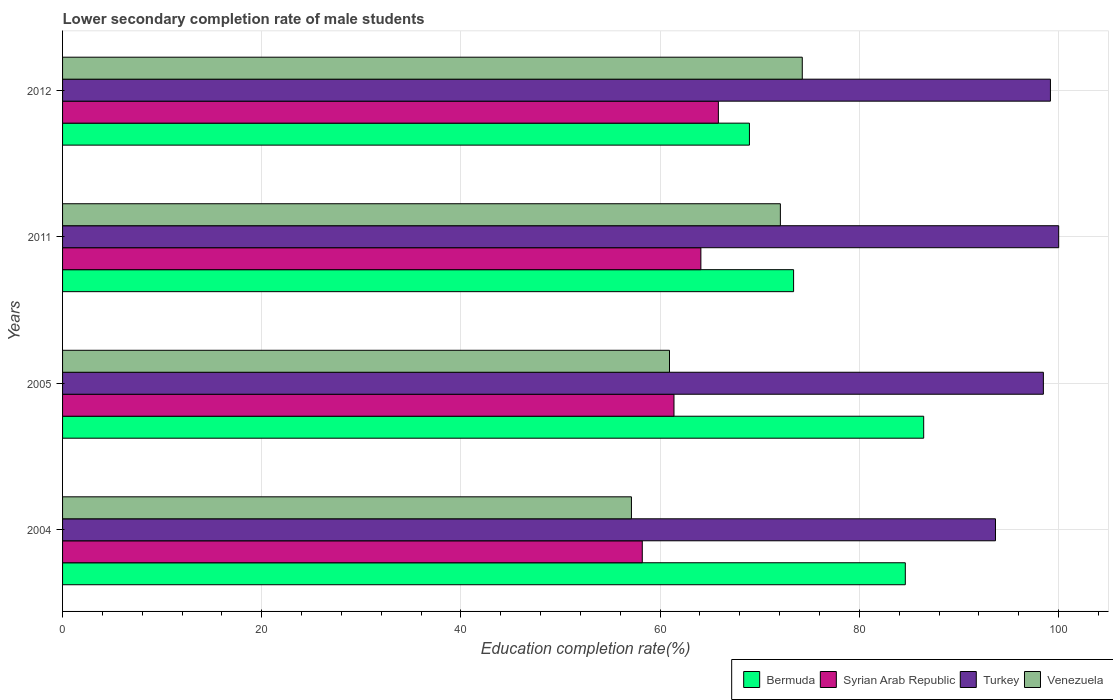How many different coloured bars are there?
Your response must be concise. 4. How many groups of bars are there?
Give a very brief answer. 4. Are the number of bars per tick equal to the number of legend labels?
Offer a very short reply. Yes. Are the number of bars on each tick of the Y-axis equal?
Make the answer very short. Yes. How many bars are there on the 2nd tick from the bottom?
Your response must be concise. 4. In how many cases, is the number of bars for a given year not equal to the number of legend labels?
Keep it short and to the point. 0. What is the lower secondary completion rate of male students in Syrian Arab Republic in 2005?
Provide a short and direct response. 61.39. Across all years, what is the maximum lower secondary completion rate of male students in Bermuda?
Make the answer very short. 86.46. Across all years, what is the minimum lower secondary completion rate of male students in Turkey?
Offer a very short reply. 93.67. In which year was the lower secondary completion rate of male students in Syrian Arab Republic maximum?
Ensure brevity in your answer.  2012. In which year was the lower secondary completion rate of male students in Syrian Arab Republic minimum?
Make the answer very short. 2004. What is the total lower secondary completion rate of male students in Bermuda in the graph?
Keep it short and to the point. 313.44. What is the difference between the lower secondary completion rate of male students in Venezuela in 2005 and that in 2012?
Your answer should be very brief. -13.33. What is the difference between the lower secondary completion rate of male students in Bermuda in 2004 and the lower secondary completion rate of male students in Venezuela in 2005?
Offer a terse response. 23.68. What is the average lower secondary completion rate of male students in Syrian Arab Republic per year?
Offer a very short reply. 62.38. In the year 2004, what is the difference between the lower secondary completion rate of male students in Bermuda and lower secondary completion rate of male students in Venezuela?
Your response must be concise. 27.5. What is the ratio of the lower secondary completion rate of male students in Syrian Arab Republic in 2004 to that in 2012?
Offer a very short reply. 0.88. What is the difference between the highest and the second highest lower secondary completion rate of male students in Turkey?
Your answer should be very brief. 0.83. What is the difference between the highest and the lowest lower secondary completion rate of male students in Turkey?
Offer a very short reply. 6.35. In how many years, is the lower secondary completion rate of male students in Turkey greater than the average lower secondary completion rate of male students in Turkey taken over all years?
Keep it short and to the point. 3. What does the 1st bar from the top in 2005 represents?
Offer a very short reply. Venezuela. What does the 4th bar from the bottom in 2011 represents?
Your answer should be compact. Venezuela. How many bars are there?
Offer a very short reply. 16. Are all the bars in the graph horizontal?
Ensure brevity in your answer.  Yes. Are the values on the major ticks of X-axis written in scientific E-notation?
Offer a very short reply. No. Does the graph contain any zero values?
Your answer should be very brief. No. Does the graph contain grids?
Offer a terse response. Yes. What is the title of the graph?
Offer a very short reply. Lower secondary completion rate of male students. Does "Middle East & North Africa (all income levels)" appear as one of the legend labels in the graph?
Your answer should be very brief. No. What is the label or title of the X-axis?
Your answer should be compact. Education completion rate(%). What is the Education completion rate(%) of Bermuda in 2004?
Your answer should be very brief. 84.62. What is the Education completion rate(%) of Syrian Arab Republic in 2004?
Ensure brevity in your answer.  58.21. What is the Education completion rate(%) of Turkey in 2004?
Keep it short and to the point. 93.67. What is the Education completion rate(%) in Venezuela in 2004?
Make the answer very short. 57.12. What is the Education completion rate(%) of Bermuda in 2005?
Offer a very short reply. 86.46. What is the Education completion rate(%) of Syrian Arab Republic in 2005?
Keep it short and to the point. 61.39. What is the Education completion rate(%) in Turkey in 2005?
Offer a very short reply. 98.48. What is the Education completion rate(%) in Venezuela in 2005?
Give a very brief answer. 60.94. What is the Education completion rate(%) in Bermuda in 2011?
Your answer should be compact. 73.4. What is the Education completion rate(%) of Syrian Arab Republic in 2011?
Your answer should be very brief. 64.09. What is the Education completion rate(%) of Turkey in 2011?
Offer a very short reply. 100.01. What is the Education completion rate(%) in Venezuela in 2011?
Keep it short and to the point. 72.07. What is the Education completion rate(%) of Bermuda in 2012?
Ensure brevity in your answer.  68.97. What is the Education completion rate(%) in Syrian Arab Republic in 2012?
Ensure brevity in your answer.  65.85. What is the Education completion rate(%) in Turkey in 2012?
Give a very brief answer. 99.19. What is the Education completion rate(%) in Venezuela in 2012?
Your response must be concise. 74.27. Across all years, what is the maximum Education completion rate(%) of Bermuda?
Make the answer very short. 86.46. Across all years, what is the maximum Education completion rate(%) in Syrian Arab Republic?
Your answer should be compact. 65.85. Across all years, what is the maximum Education completion rate(%) of Turkey?
Offer a terse response. 100.01. Across all years, what is the maximum Education completion rate(%) of Venezuela?
Offer a very short reply. 74.27. Across all years, what is the minimum Education completion rate(%) of Bermuda?
Your answer should be very brief. 68.97. Across all years, what is the minimum Education completion rate(%) of Syrian Arab Republic?
Provide a short and direct response. 58.21. Across all years, what is the minimum Education completion rate(%) of Turkey?
Keep it short and to the point. 93.67. Across all years, what is the minimum Education completion rate(%) of Venezuela?
Offer a terse response. 57.12. What is the total Education completion rate(%) in Bermuda in the graph?
Offer a very short reply. 313.44. What is the total Education completion rate(%) of Syrian Arab Republic in the graph?
Ensure brevity in your answer.  249.53. What is the total Education completion rate(%) in Turkey in the graph?
Your answer should be compact. 391.35. What is the total Education completion rate(%) of Venezuela in the graph?
Your answer should be very brief. 264.4. What is the difference between the Education completion rate(%) in Bermuda in 2004 and that in 2005?
Offer a very short reply. -1.85. What is the difference between the Education completion rate(%) of Syrian Arab Republic in 2004 and that in 2005?
Make the answer very short. -3.18. What is the difference between the Education completion rate(%) in Turkey in 2004 and that in 2005?
Your answer should be very brief. -4.81. What is the difference between the Education completion rate(%) of Venezuela in 2004 and that in 2005?
Provide a short and direct response. -3.82. What is the difference between the Education completion rate(%) of Bermuda in 2004 and that in 2011?
Offer a terse response. 11.22. What is the difference between the Education completion rate(%) of Syrian Arab Republic in 2004 and that in 2011?
Offer a very short reply. -5.88. What is the difference between the Education completion rate(%) of Turkey in 2004 and that in 2011?
Offer a terse response. -6.35. What is the difference between the Education completion rate(%) in Venezuela in 2004 and that in 2011?
Offer a very short reply. -14.95. What is the difference between the Education completion rate(%) of Bermuda in 2004 and that in 2012?
Keep it short and to the point. 15.65. What is the difference between the Education completion rate(%) of Syrian Arab Republic in 2004 and that in 2012?
Your answer should be very brief. -7.64. What is the difference between the Education completion rate(%) in Turkey in 2004 and that in 2012?
Your response must be concise. -5.52. What is the difference between the Education completion rate(%) in Venezuela in 2004 and that in 2012?
Your answer should be very brief. -17.15. What is the difference between the Education completion rate(%) in Bermuda in 2005 and that in 2011?
Provide a short and direct response. 13.06. What is the difference between the Education completion rate(%) in Syrian Arab Republic in 2005 and that in 2011?
Ensure brevity in your answer.  -2.7. What is the difference between the Education completion rate(%) in Turkey in 2005 and that in 2011?
Provide a short and direct response. -1.54. What is the difference between the Education completion rate(%) of Venezuela in 2005 and that in 2011?
Your answer should be very brief. -11.13. What is the difference between the Education completion rate(%) of Bermuda in 2005 and that in 2012?
Offer a terse response. 17.5. What is the difference between the Education completion rate(%) of Syrian Arab Republic in 2005 and that in 2012?
Your response must be concise. -4.46. What is the difference between the Education completion rate(%) in Turkey in 2005 and that in 2012?
Offer a terse response. -0.71. What is the difference between the Education completion rate(%) of Venezuela in 2005 and that in 2012?
Provide a succinct answer. -13.33. What is the difference between the Education completion rate(%) in Bermuda in 2011 and that in 2012?
Offer a terse response. 4.43. What is the difference between the Education completion rate(%) of Syrian Arab Republic in 2011 and that in 2012?
Your answer should be compact. -1.76. What is the difference between the Education completion rate(%) in Turkey in 2011 and that in 2012?
Your response must be concise. 0.83. What is the difference between the Education completion rate(%) of Venezuela in 2011 and that in 2012?
Ensure brevity in your answer.  -2.2. What is the difference between the Education completion rate(%) of Bermuda in 2004 and the Education completion rate(%) of Syrian Arab Republic in 2005?
Offer a very short reply. 23.23. What is the difference between the Education completion rate(%) of Bermuda in 2004 and the Education completion rate(%) of Turkey in 2005?
Provide a short and direct response. -13.86. What is the difference between the Education completion rate(%) in Bermuda in 2004 and the Education completion rate(%) in Venezuela in 2005?
Make the answer very short. 23.68. What is the difference between the Education completion rate(%) in Syrian Arab Republic in 2004 and the Education completion rate(%) in Turkey in 2005?
Give a very brief answer. -40.27. What is the difference between the Education completion rate(%) of Syrian Arab Republic in 2004 and the Education completion rate(%) of Venezuela in 2005?
Provide a short and direct response. -2.73. What is the difference between the Education completion rate(%) in Turkey in 2004 and the Education completion rate(%) in Venezuela in 2005?
Provide a short and direct response. 32.73. What is the difference between the Education completion rate(%) in Bermuda in 2004 and the Education completion rate(%) in Syrian Arab Republic in 2011?
Your response must be concise. 20.53. What is the difference between the Education completion rate(%) of Bermuda in 2004 and the Education completion rate(%) of Turkey in 2011?
Your response must be concise. -15.4. What is the difference between the Education completion rate(%) of Bermuda in 2004 and the Education completion rate(%) of Venezuela in 2011?
Keep it short and to the point. 12.54. What is the difference between the Education completion rate(%) of Syrian Arab Republic in 2004 and the Education completion rate(%) of Turkey in 2011?
Give a very brief answer. -41.81. What is the difference between the Education completion rate(%) in Syrian Arab Republic in 2004 and the Education completion rate(%) in Venezuela in 2011?
Your response must be concise. -13.87. What is the difference between the Education completion rate(%) of Turkey in 2004 and the Education completion rate(%) of Venezuela in 2011?
Ensure brevity in your answer.  21.6. What is the difference between the Education completion rate(%) of Bermuda in 2004 and the Education completion rate(%) of Syrian Arab Republic in 2012?
Provide a succinct answer. 18.77. What is the difference between the Education completion rate(%) in Bermuda in 2004 and the Education completion rate(%) in Turkey in 2012?
Provide a short and direct response. -14.57. What is the difference between the Education completion rate(%) in Bermuda in 2004 and the Education completion rate(%) in Venezuela in 2012?
Offer a very short reply. 10.35. What is the difference between the Education completion rate(%) in Syrian Arab Republic in 2004 and the Education completion rate(%) in Turkey in 2012?
Give a very brief answer. -40.98. What is the difference between the Education completion rate(%) of Syrian Arab Republic in 2004 and the Education completion rate(%) of Venezuela in 2012?
Make the answer very short. -16.06. What is the difference between the Education completion rate(%) in Turkey in 2004 and the Education completion rate(%) in Venezuela in 2012?
Ensure brevity in your answer.  19.4. What is the difference between the Education completion rate(%) in Bermuda in 2005 and the Education completion rate(%) in Syrian Arab Republic in 2011?
Offer a very short reply. 22.37. What is the difference between the Education completion rate(%) of Bermuda in 2005 and the Education completion rate(%) of Turkey in 2011?
Make the answer very short. -13.55. What is the difference between the Education completion rate(%) in Bermuda in 2005 and the Education completion rate(%) in Venezuela in 2011?
Make the answer very short. 14.39. What is the difference between the Education completion rate(%) of Syrian Arab Republic in 2005 and the Education completion rate(%) of Turkey in 2011?
Make the answer very short. -38.63. What is the difference between the Education completion rate(%) of Syrian Arab Republic in 2005 and the Education completion rate(%) of Venezuela in 2011?
Provide a short and direct response. -10.68. What is the difference between the Education completion rate(%) of Turkey in 2005 and the Education completion rate(%) of Venezuela in 2011?
Your response must be concise. 26.41. What is the difference between the Education completion rate(%) in Bermuda in 2005 and the Education completion rate(%) in Syrian Arab Republic in 2012?
Your response must be concise. 20.61. What is the difference between the Education completion rate(%) in Bermuda in 2005 and the Education completion rate(%) in Turkey in 2012?
Keep it short and to the point. -12.73. What is the difference between the Education completion rate(%) of Bermuda in 2005 and the Education completion rate(%) of Venezuela in 2012?
Make the answer very short. 12.19. What is the difference between the Education completion rate(%) of Syrian Arab Republic in 2005 and the Education completion rate(%) of Turkey in 2012?
Offer a terse response. -37.8. What is the difference between the Education completion rate(%) in Syrian Arab Republic in 2005 and the Education completion rate(%) in Venezuela in 2012?
Your answer should be very brief. -12.88. What is the difference between the Education completion rate(%) of Turkey in 2005 and the Education completion rate(%) of Venezuela in 2012?
Provide a short and direct response. 24.21. What is the difference between the Education completion rate(%) in Bermuda in 2011 and the Education completion rate(%) in Syrian Arab Republic in 2012?
Give a very brief answer. 7.55. What is the difference between the Education completion rate(%) of Bermuda in 2011 and the Education completion rate(%) of Turkey in 2012?
Offer a very short reply. -25.79. What is the difference between the Education completion rate(%) in Bermuda in 2011 and the Education completion rate(%) in Venezuela in 2012?
Give a very brief answer. -0.87. What is the difference between the Education completion rate(%) in Syrian Arab Republic in 2011 and the Education completion rate(%) in Turkey in 2012?
Offer a very short reply. -35.1. What is the difference between the Education completion rate(%) in Syrian Arab Republic in 2011 and the Education completion rate(%) in Venezuela in 2012?
Provide a short and direct response. -10.18. What is the difference between the Education completion rate(%) in Turkey in 2011 and the Education completion rate(%) in Venezuela in 2012?
Give a very brief answer. 25.74. What is the average Education completion rate(%) of Bermuda per year?
Your answer should be very brief. 78.36. What is the average Education completion rate(%) in Syrian Arab Republic per year?
Your response must be concise. 62.38. What is the average Education completion rate(%) in Turkey per year?
Your answer should be compact. 97.84. What is the average Education completion rate(%) in Venezuela per year?
Provide a short and direct response. 66.1. In the year 2004, what is the difference between the Education completion rate(%) of Bermuda and Education completion rate(%) of Syrian Arab Republic?
Offer a very short reply. 26.41. In the year 2004, what is the difference between the Education completion rate(%) of Bermuda and Education completion rate(%) of Turkey?
Your response must be concise. -9.05. In the year 2004, what is the difference between the Education completion rate(%) of Bermuda and Education completion rate(%) of Venezuela?
Your answer should be compact. 27.5. In the year 2004, what is the difference between the Education completion rate(%) in Syrian Arab Republic and Education completion rate(%) in Turkey?
Offer a terse response. -35.46. In the year 2004, what is the difference between the Education completion rate(%) of Syrian Arab Republic and Education completion rate(%) of Venezuela?
Ensure brevity in your answer.  1.09. In the year 2004, what is the difference between the Education completion rate(%) in Turkey and Education completion rate(%) in Venezuela?
Your answer should be compact. 36.55. In the year 2005, what is the difference between the Education completion rate(%) in Bermuda and Education completion rate(%) in Syrian Arab Republic?
Make the answer very short. 25.07. In the year 2005, what is the difference between the Education completion rate(%) of Bermuda and Education completion rate(%) of Turkey?
Keep it short and to the point. -12.02. In the year 2005, what is the difference between the Education completion rate(%) of Bermuda and Education completion rate(%) of Venezuela?
Your answer should be very brief. 25.52. In the year 2005, what is the difference between the Education completion rate(%) of Syrian Arab Republic and Education completion rate(%) of Turkey?
Make the answer very short. -37.09. In the year 2005, what is the difference between the Education completion rate(%) in Syrian Arab Republic and Education completion rate(%) in Venezuela?
Keep it short and to the point. 0.45. In the year 2005, what is the difference between the Education completion rate(%) in Turkey and Education completion rate(%) in Venezuela?
Your response must be concise. 37.54. In the year 2011, what is the difference between the Education completion rate(%) of Bermuda and Education completion rate(%) of Syrian Arab Republic?
Offer a terse response. 9.31. In the year 2011, what is the difference between the Education completion rate(%) in Bermuda and Education completion rate(%) in Turkey?
Ensure brevity in your answer.  -26.62. In the year 2011, what is the difference between the Education completion rate(%) of Bermuda and Education completion rate(%) of Venezuela?
Give a very brief answer. 1.33. In the year 2011, what is the difference between the Education completion rate(%) of Syrian Arab Republic and Education completion rate(%) of Turkey?
Offer a very short reply. -35.93. In the year 2011, what is the difference between the Education completion rate(%) in Syrian Arab Republic and Education completion rate(%) in Venezuela?
Ensure brevity in your answer.  -7.98. In the year 2011, what is the difference between the Education completion rate(%) in Turkey and Education completion rate(%) in Venezuela?
Your answer should be very brief. 27.94. In the year 2012, what is the difference between the Education completion rate(%) of Bermuda and Education completion rate(%) of Syrian Arab Republic?
Give a very brief answer. 3.12. In the year 2012, what is the difference between the Education completion rate(%) in Bermuda and Education completion rate(%) in Turkey?
Give a very brief answer. -30.22. In the year 2012, what is the difference between the Education completion rate(%) in Bermuda and Education completion rate(%) in Venezuela?
Give a very brief answer. -5.3. In the year 2012, what is the difference between the Education completion rate(%) in Syrian Arab Republic and Education completion rate(%) in Turkey?
Make the answer very short. -33.34. In the year 2012, what is the difference between the Education completion rate(%) in Syrian Arab Republic and Education completion rate(%) in Venezuela?
Provide a succinct answer. -8.42. In the year 2012, what is the difference between the Education completion rate(%) of Turkey and Education completion rate(%) of Venezuela?
Keep it short and to the point. 24.92. What is the ratio of the Education completion rate(%) in Bermuda in 2004 to that in 2005?
Offer a terse response. 0.98. What is the ratio of the Education completion rate(%) of Syrian Arab Republic in 2004 to that in 2005?
Make the answer very short. 0.95. What is the ratio of the Education completion rate(%) in Turkey in 2004 to that in 2005?
Give a very brief answer. 0.95. What is the ratio of the Education completion rate(%) of Venezuela in 2004 to that in 2005?
Your answer should be compact. 0.94. What is the ratio of the Education completion rate(%) of Bermuda in 2004 to that in 2011?
Give a very brief answer. 1.15. What is the ratio of the Education completion rate(%) of Syrian Arab Republic in 2004 to that in 2011?
Offer a very short reply. 0.91. What is the ratio of the Education completion rate(%) in Turkey in 2004 to that in 2011?
Keep it short and to the point. 0.94. What is the ratio of the Education completion rate(%) in Venezuela in 2004 to that in 2011?
Give a very brief answer. 0.79. What is the ratio of the Education completion rate(%) in Bermuda in 2004 to that in 2012?
Provide a short and direct response. 1.23. What is the ratio of the Education completion rate(%) of Syrian Arab Republic in 2004 to that in 2012?
Provide a short and direct response. 0.88. What is the ratio of the Education completion rate(%) in Venezuela in 2004 to that in 2012?
Offer a very short reply. 0.77. What is the ratio of the Education completion rate(%) of Bermuda in 2005 to that in 2011?
Give a very brief answer. 1.18. What is the ratio of the Education completion rate(%) of Syrian Arab Republic in 2005 to that in 2011?
Offer a terse response. 0.96. What is the ratio of the Education completion rate(%) of Turkey in 2005 to that in 2011?
Provide a succinct answer. 0.98. What is the ratio of the Education completion rate(%) of Venezuela in 2005 to that in 2011?
Keep it short and to the point. 0.85. What is the ratio of the Education completion rate(%) in Bermuda in 2005 to that in 2012?
Your response must be concise. 1.25. What is the ratio of the Education completion rate(%) of Syrian Arab Republic in 2005 to that in 2012?
Ensure brevity in your answer.  0.93. What is the ratio of the Education completion rate(%) of Turkey in 2005 to that in 2012?
Offer a terse response. 0.99. What is the ratio of the Education completion rate(%) of Venezuela in 2005 to that in 2012?
Give a very brief answer. 0.82. What is the ratio of the Education completion rate(%) in Bermuda in 2011 to that in 2012?
Make the answer very short. 1.06. What is the ratio of the Education completion rate(%) of Syrian Arab Republic in 2011 to that in 2012?
Make the answer very short. 0.97. What is the ratio of the Education completion rate(%) of Turkey in 2011 to that in 2012?
Provide a succinct answer. 1.01. What is the ratio of the Education completion rate(%) in Venezuela in 2011 to that in 2012?
Provide a short and direct response. 0.97. What is the difference between the highest and the second highest Education completion rate(%) of Bermuda?
Your response must be concise. 1.85. What is the difference between the highest and the second highest Education completion rate(%) of Syrian Arab Republic?
Your response must be concise. 1.76. What is the difference between the highest and the second highest Education completion rate(%) in Turkey?
Offer a terse response. 0.83. What is the difference between the highest and the second highest Education completion rate(%) of Venezuela?
Your answer should be compact. 2.2. What is the difference between the highest and the lowest Education completion rate(%) in Bermuda?
Your response must be concise. 17.5. What is the difference between the highest and the lowest Education completion rate(%) of Syrian Arab Republic?
Your answer should be compact. 7.64. What is the difference between the highest and the lowest Education completion rate(%) of Turkey?
Your answer should be very brief. 6.35. What is the difference between the highest and the lowest Education completion rate(%) in Venezuela?
Ensure brevity in your answer.  17.15. 